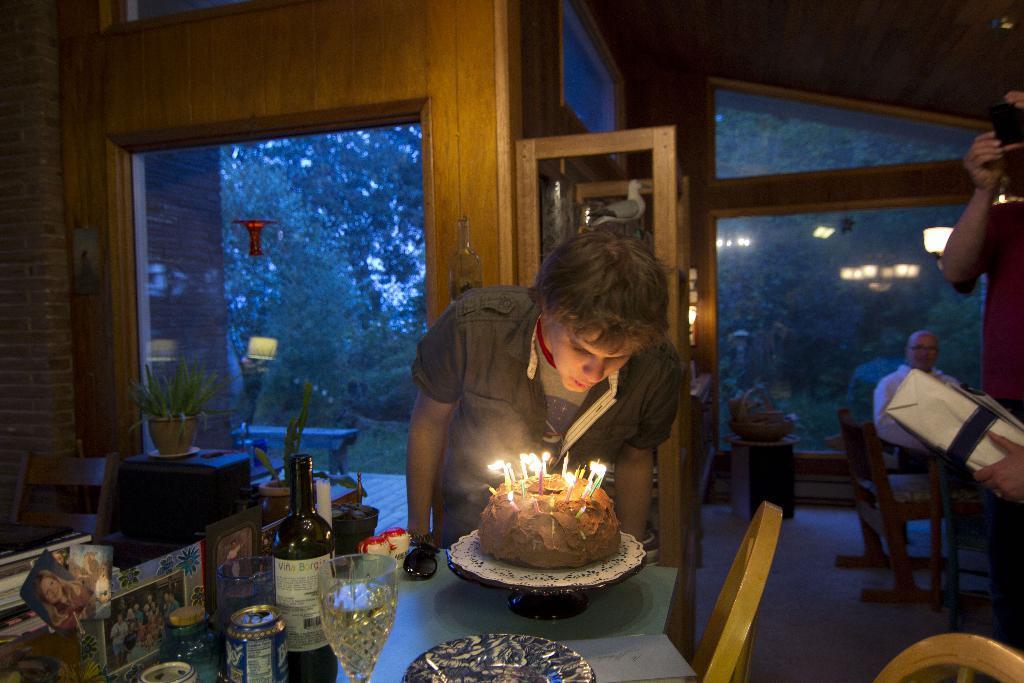Please provide a concise description of this image. In this image there are three persons. It is clicked inside the house. To the left, there is a table on which there are bottles, glasses and photos. In the front, there is a man blowing the candles on the cake. 